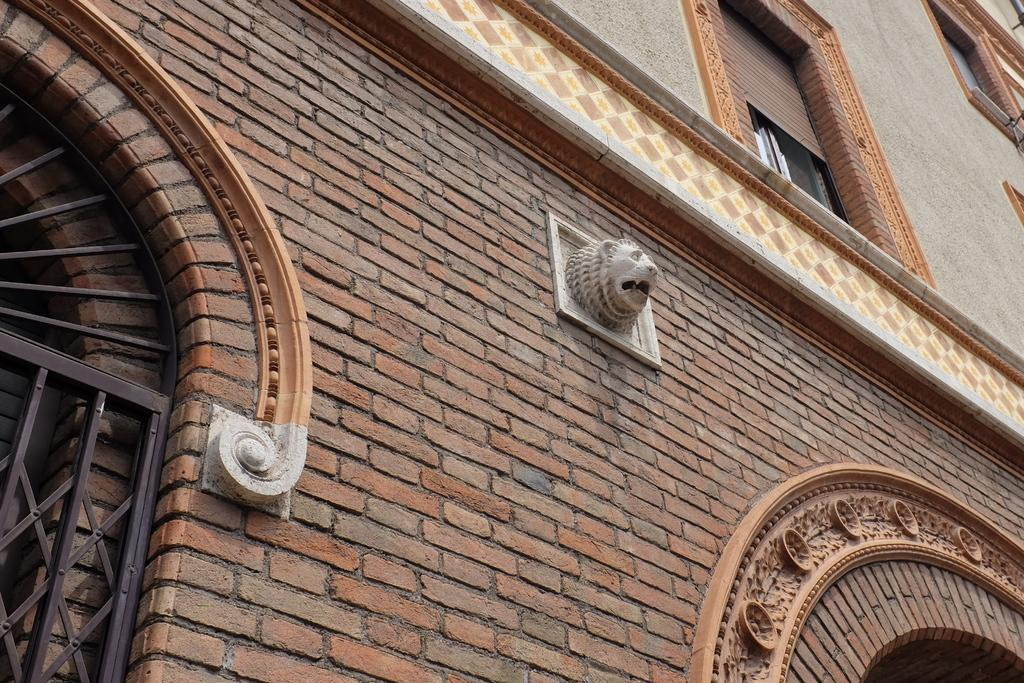What is the main subject of the image? The main subject of the image is a building. What type of design can be seen on the yam in the image? There is no yam present in the image, and therefore no design can be observed on it. What type of fruit is hanging from the building in the image? There is no fruit hanging from the building in the image. 